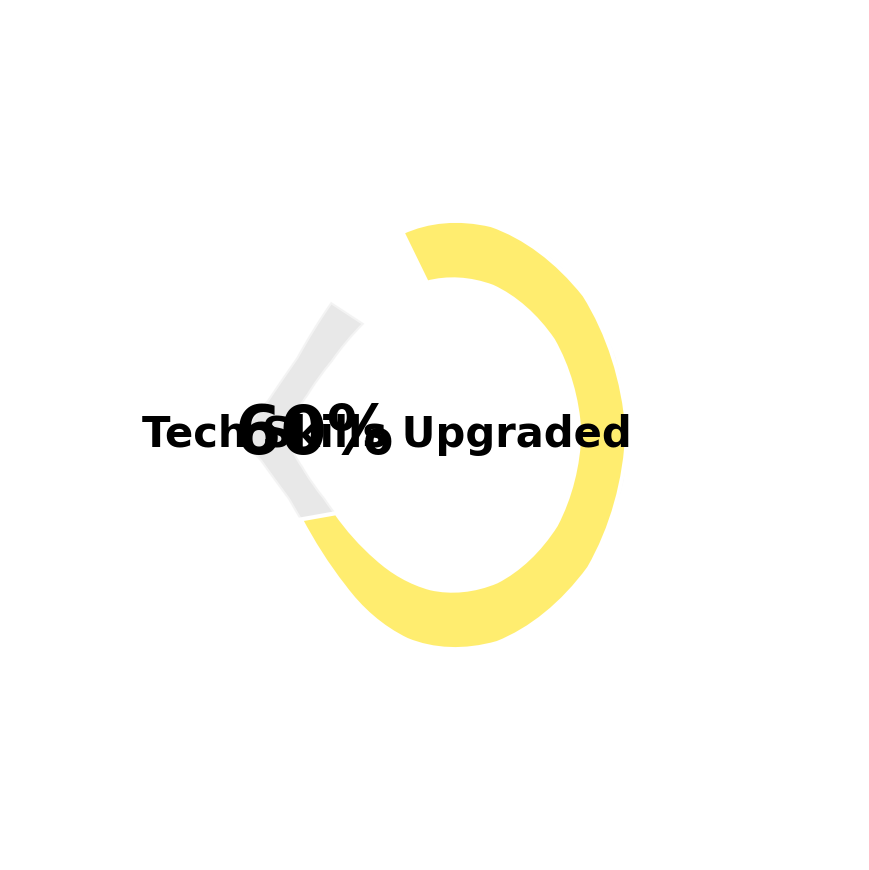What's the title of this figure? The title is displayed at the top of the figure.
Answer: Job Search Progress for BU Alumni in Tech How many gauge charts are there in the figure? Count each individual gauge chart visible in the figure.
Answer: 8 Which gauge chart shows the highest percentage progress? Compare the percentages shown at the bottom of each gauge chart. The gauge with the highest percentage indicates the highest progress.
Answer: LinkedIn Connections Made In which area has the least progress been made? Look for the gauge chart with the smallest percentage shown at the bottom.
Answer: Job Offers Received What percentage of coding challenges have been completed? Identify the gauge titled "Coding Challenges Completed" and read the percentage shown at the bottom.
Answer: 50% What is the combined maximum target for Job Offers Received and Tech Skills Upgraded? Add the maximum values for both "Job Offers Received" and "Tech Skills Upgraded" as indicated on their respective gauges.
Answer: 20 If 50% completion corresponds to 30 coding challenges, what’s the number of completed coding challenges? 50% of 30 equals 15, which matches the "Coding Challenges Completed" gauge reading.
Answer: 15 Compare the progress in Applications Submitted and Interviews Scheduled. Which has a higher percentage? Check the percentages shown for "Applications Submitted" and "Interviews Scheduled", and see which is higher.
Answer: Applications Submitted What percentage of the total target of Tech Meetups has been attended? Identify the gauge titled "Tech Meetups Attended" and read the percentage shown at the bottom.
Answer: 40% What is the average progress (percentage) shown across all gauge charts? Calculate the average of the percentages shown at the bottom of all eight gauge charts: (75% + 48% + 20% + 60% + 40% + 50% + 40% + 60%) / 8.
Answer: 49.13% 